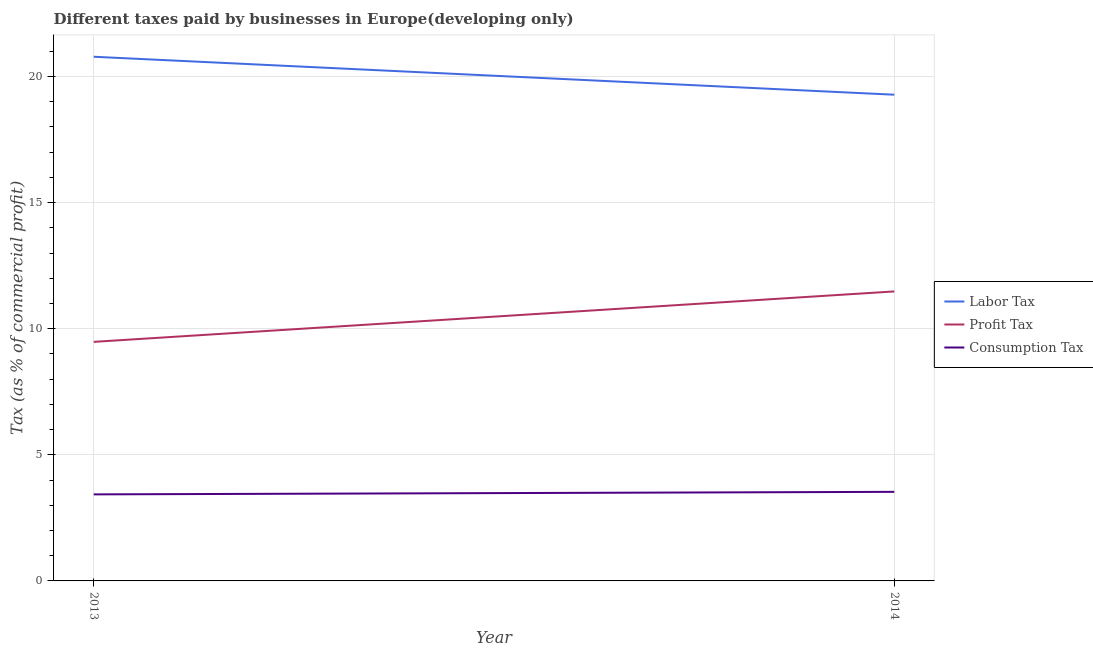What is the percentage of labor tax in 2013?
Offer a very short reply. 20.78. Across all years, what is the maximum percentage of consumption tax?
Your response must be concise. 3.53. Across all years, what is the minimum percentage of labor tax?
Provide a succinct answer. 19.28. In which year was the percentage of consumption tax maximum?
Make the answer very short. 2014. What is the total percentage of labor tax in the graph?
Ensure brevity in your answer.  40.06. What is the difference between the percentage of profit tax in 2013 and that in 2014?
Keep it short and to the point. -2. What is the difference between the percentage of consumption tax in 2013 and the percentage of labor tax in 2014?
Your answer should be very brief. -15.85. What is the average percentage of labor tax per year?
Make the answer very short. 20.03. In the year 2014, what is the difference between the percentage of consumption tax and percentage of profit tax?
Your answer should be compact. -7.95. What is the ratio of the percentage of profit tax in 2013 to that in 2014?
Your answer should be very brief. 0.83. Is the percentage of consumption tax in 2013 less than that in 2014?
Give a very brief answer. Yes. In how many years, is the percentage of labor tax greater than the average percentage of labor tax taken over all years?
Provide a short and direct response. 1. Does the percentage of labor tax monotonically increase over the years?
Keep it short and to the point. No. Is the percentage of labor tax strictly less than the percentage of profit tax over the years?
Your answer should be very brief. No. How many lines are there?
Offer a very short reply. 3. Are the values on the major ticks of Y-axis written in scientific E-notation?
Your answer should be very brief. No. How many legend labels are there?
Ensure brevity in your answer.  3. How are the legend labels stacked?
Ensure brevity in your answer.  Vertical. What is the title of the graph?
Keep it short and to the point. Different taxes paid by businesses in Europe(developing only). What is the label or title of the X-axis?
Give a very brief answer. Year. What is the label or title of the Y-axis?
Offer a terse response. Tax (as % of commercial profit). What is the Tax (as % of commercial profit) of Labor Tax in 2013?
Offer a terse response. 20.78. What is the Tax (as % of commercial profit) in Profit Tax in 2013?
Give a very brief answer. 9.48. What is the Tax (as % of commercial profit) in Consumption Tax in 2013?
Provide a short and direct response. 3.43. What is the Tax (as % of commercial profit) in Labor Tax in 2014?
Provide a short and direct response. 19.28. What is the Tax (as % of commercial profit) of Profit Tax in 2014?
Provide a short and direct response. 11.48. What is the Tax (as % of commercial profit) in Consumption Tax in 2014?
Ensure brevity in your answer.  3.53. Across all years, what is the maximum Tax (as % of commercial profit) in Labor Tax?
Keep it short and to the point. 20.78. Across all years, what is the maximum Tax (as % of commercial profit) of Profit Tax?
Make the answer very short. 11.48. Across all years, what is the maximum Tax (as % of commercial profit) in Consumption Tax?
Your answer should be compact. 3.53. Across all years, what is the minimum Tax (as % of commercial profit) in Labor Tax?
Your answer should be very brief. 19.28. Across all years, what is the minimum Tax (as % of commercial profit) in Profit Tax?
Keep it short and to the point. 9.48. Across all years, what is the minimum Tax (as % of commercial profit) in Consumption Tax?
Make the answer very short. 3.43. What is the total Tax (as % of commercial profit) of Labor Tax in the graph?
Your answer should be very brief. 40.06. What is the total Tax (as % of commercial profit) of Profit Tax in the graph?
Provide a short and direct response. 20.96. What is the total Tax (as % of commercial profit) of Consumption Tax in the graph?
Keep it short and to the point. 6.96. What is the difference between the Tax (as % of commercial profit) in Labor Tax in 2013 and that in 2014?
Provide a succinct answer. 1.51. What is the difference between the Tax (as % of commercial profit) of Profit Tax in 2013 and that in 2014?
Keep it short and to the point. -2. What is the difference between the Tax (as % of commercial profit) of Consumption Tax in 2013 and that in 2014?
Your answer should be very brief. -0.1. What is the difference between the Tax (as % of commercial profit) of Labor Tax in 2013 and the Tax (as % of commercial profit) of Profit Tax in 2014?
Your response must be concise. 9.31. What is the difference between the Tax (as % of commercial profit) of Labor Tax in 2013 and the Tax (as % of commercial profit) of Consumption Tax in 2014?
Offer a terse response. 17.25. What is the difference between the Tax (as % of commercial profit) of Profit Tax in 2013 and the Tax (as % of commercial profit) of Consumption Tax in 2014?
Provide a short and direct response. 5.95. What is the average Tax (as % of commercial profit) in Labor Tax per year?
Your answer should be compact. 20.03. What is the average Tax (as % of commercial profit) of Profit Tax per year?
Your response must be concise. 10.48. What is the average Tax (as % of commercial profit) of Consumption Tax per year?
Provide a short and direct response. 3.48. In the year 2013, what is the difference between the Tax (as % of commercial profit) in Labor Tax and Tax (as % of commercial profit) in Profit Tax?
Offer a terse response. 11.31. In the year 2013, what is the difference between the Tax (as % of commercial profit) in Labor Tax and Tax (as % of commercial profit) in Consumption Tax?
Your answer should be very brief. 17.35. In the year 2013, what is the difference between the Tax (as % of commercial profit) in Profit Tax and Tax (as % of commercial profit) in Consumption Tax?
Provide a succinct answer. 6.05. In the year 2014, what is the difference between the Tax (as % of commercial profit) of Labor Tax and Tax (as % of commercial profit) of Profit Tax?
Your response must be concise. 7.8. In the year 2014, what is the difference between the Tax (as % of commercial profit) of Labor Tax and Tax (as % of commercial profit) of Consumption Tax?
Make the answer very short. 15.75. In the year 2014, what is the difference between the Tax (as % of commercial profit) of Profit Tax and Tax (as % of commercial profit) of Consumption Tax?
Provide a succinct answer. 7.95. What is the ratio of the Tax (as % of commercial profit) in Labor Tax in 2013 to that in 2014?
Offer a very short reply. 1.08. What is the ratio of the Tax (as % of commercial profit) of Profit Tax in 2013 to that in 2014?
Keep it short and to the point. 0.83. What is the ratio of the Tax (as % of commercial profit) of Consumption Tax in 2013 to that in 2014?
Provide a short and direct response. 0.97. What is the difference between the highest and the second highest Tax (as % of commercial profit) in Labor Tax?
Your response must be concise. 1.51. What is the difference between the highest and the second highest Tax (as % of commercial profit) in Profit Tax?
Provide a succinct answer. 2. What is the difference between the highest and the lowest Tax (as % of commercial profit) of Labor Tax?
Provide a succinct answer. 1.51. What is the difference between the highest and the lowest Tax (as % of commercial profit) in Profit Tax?
Provide a succinct answer. 2. 